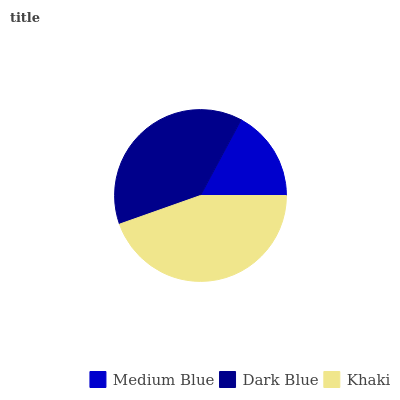Is Medium Blue the minimum?
Answer yes or no. Yes. Is Khaki the maximum?
Answer yes or no. Yes. Is Dark Blue the minimum?
Answer yes or no. No. Is Dark Blue the maximum?
Answer yes or no. No. Is Dark Blue greater than Medium Blue?
Answer yes or no. Yes. Is Medium Blue less than Dark Blue?
Answer yes or no. Yes. Is Medium Blue greater than Dark Blue?
Answer yes or no. No. Is Dark Blue less than Medium Blue?
Answer yes or no. No. Is Dark Blue the high median?
Answer yes or no. Yes. Is Dark Blue the low median?
Answer yes or no. Yes. Is Khaki the high median?
Answer yes or no. No. Is Khaki the low median?
Answer yes or no. No. 